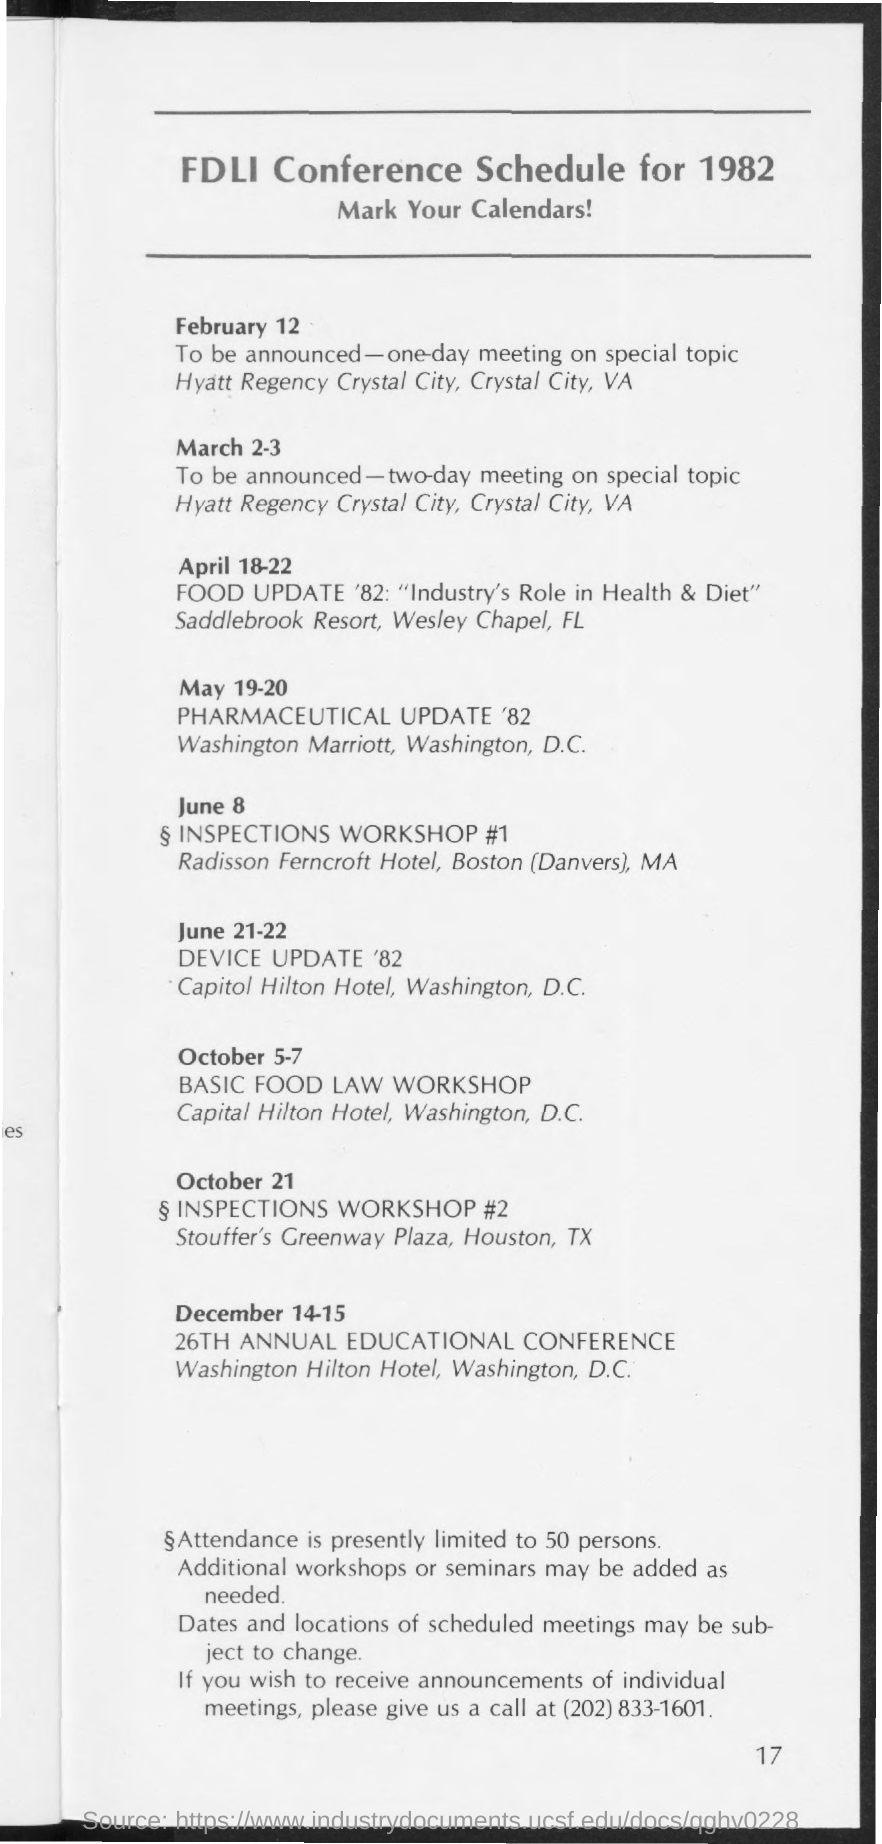Draw attention to some important aspects in this diagram. The page number of this document is 17. The title of the document is "FDLI Conference Schedule for 1982. The phone number written in the document is (202) 833-1601. On the 26th day of the 12th month of the current year, the 26th Annual Educational Conference was held at the Washington Hilton Hotel in Washington, D.C. 